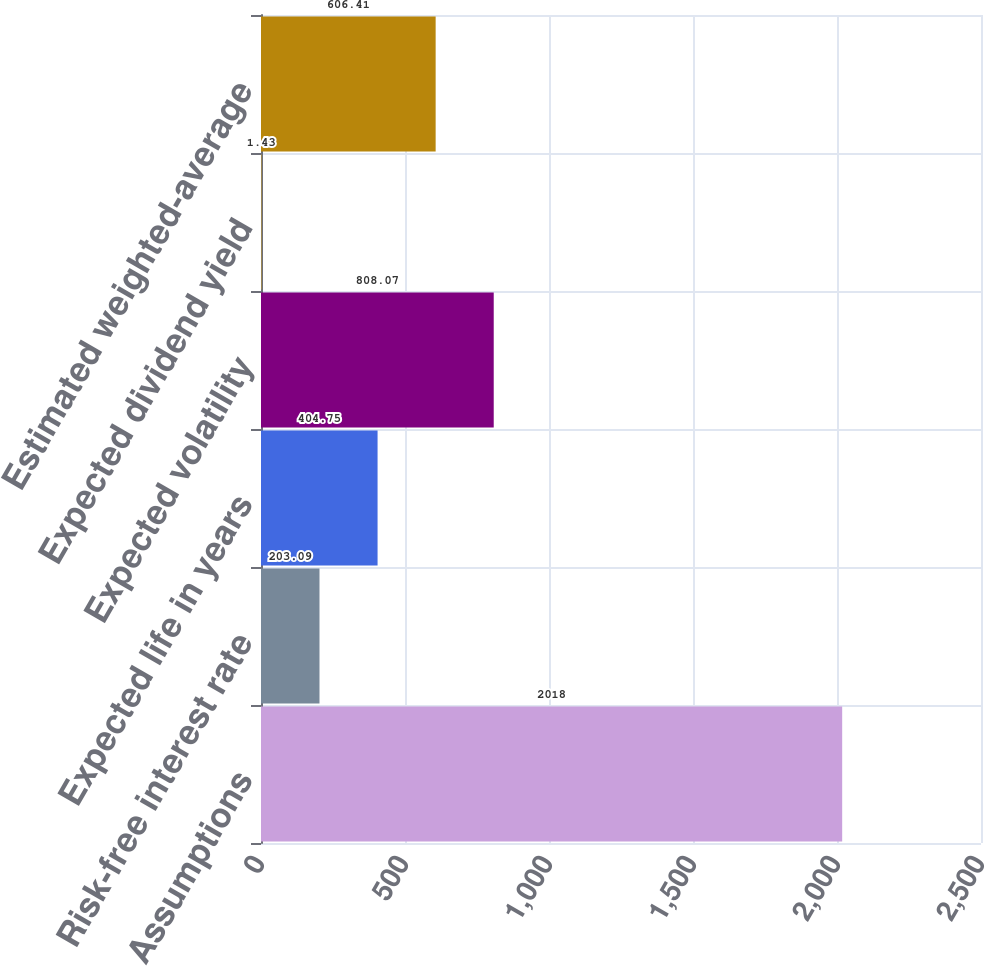Convert chart. <chart><loc_0><loc_0><loc_500><loc_500><bar_chart><fcel>Assumptions<fcel>Risk-free interest rate<fcel>Expected life in years<fcel>Expected volatility<fcel>Expected dividend yield<fcel>Estimated weighted-average<nl><fcel>2018<fcel>203.09<fcel>404.75<fcel>808.07<fcel>1.43<fcel>606.41<nl></chart> 